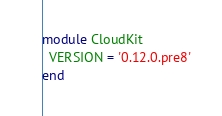<code> <loc_0><loc_0><loc_500><loc_500><_Ruby_>module CloudKit
  VERSION = '0.12.0.pre8'
end
</code> 